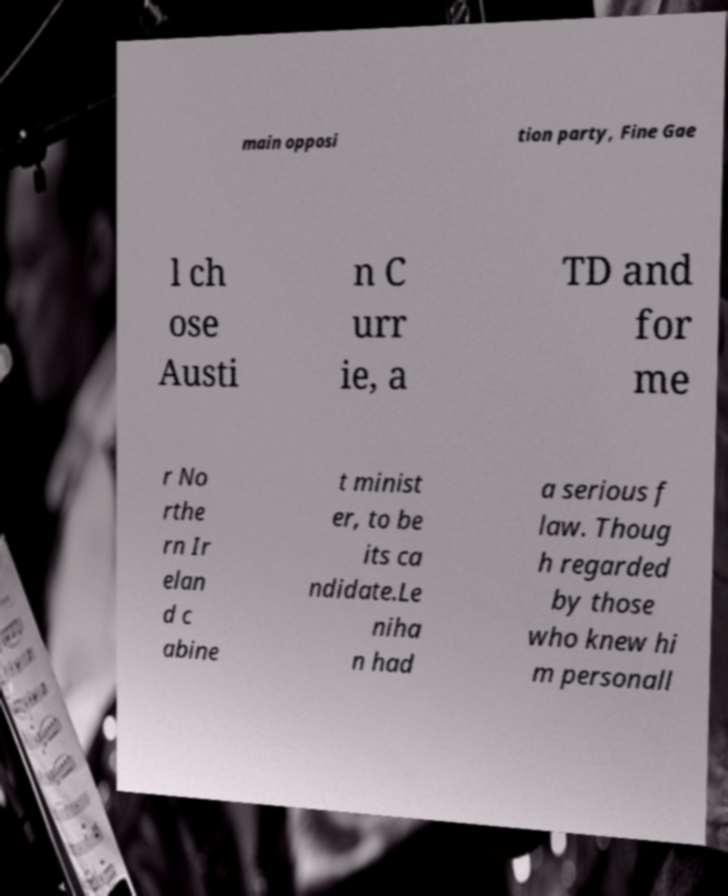There's text embedded in this image that I need extracted. Can you transcribe it verbatim? main opposi tion party, Fine Gae l ch ose Austi n C urr ie, a TD and for me r No rthe rn Ir elan d c abine t minist er, to be its ca ndidate.Le niha n had a serious f law. Thoug h regarded by those who knew hi m personall 